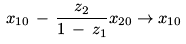<formula> <loc_0><loc_0><loc_500><loc_500>x _ { 1 0 } \, - \, \frac { z _ { 2 } } { 1 \, - \, z _ { 1 } } x _ { 2 0 } \rightarrow x _ { 1 0 }</formula> 